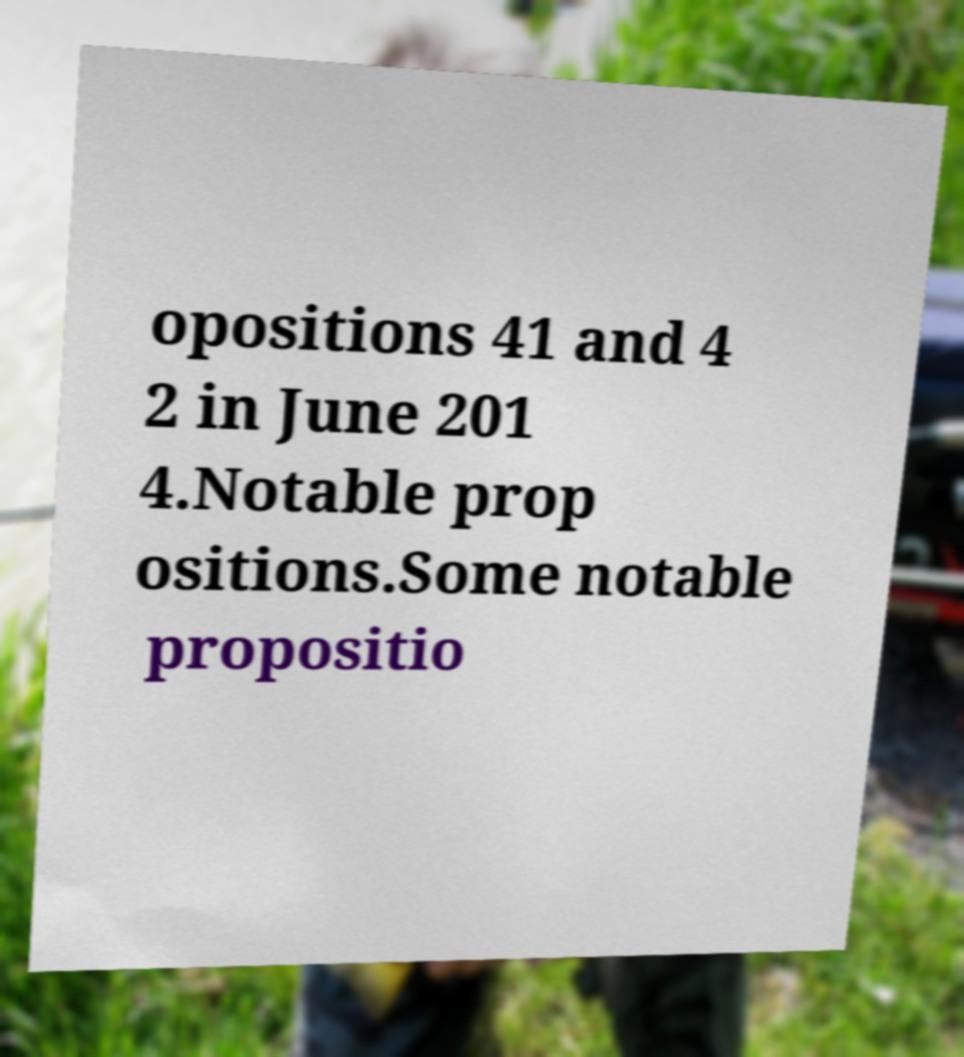Can you read and provide the text displayed in the image?This photo seems to have some interesting text. Can you extract and type it out for me? opositions 41 and 4 2 in June 201 4.Notable prop ositions.Some notable propositio 